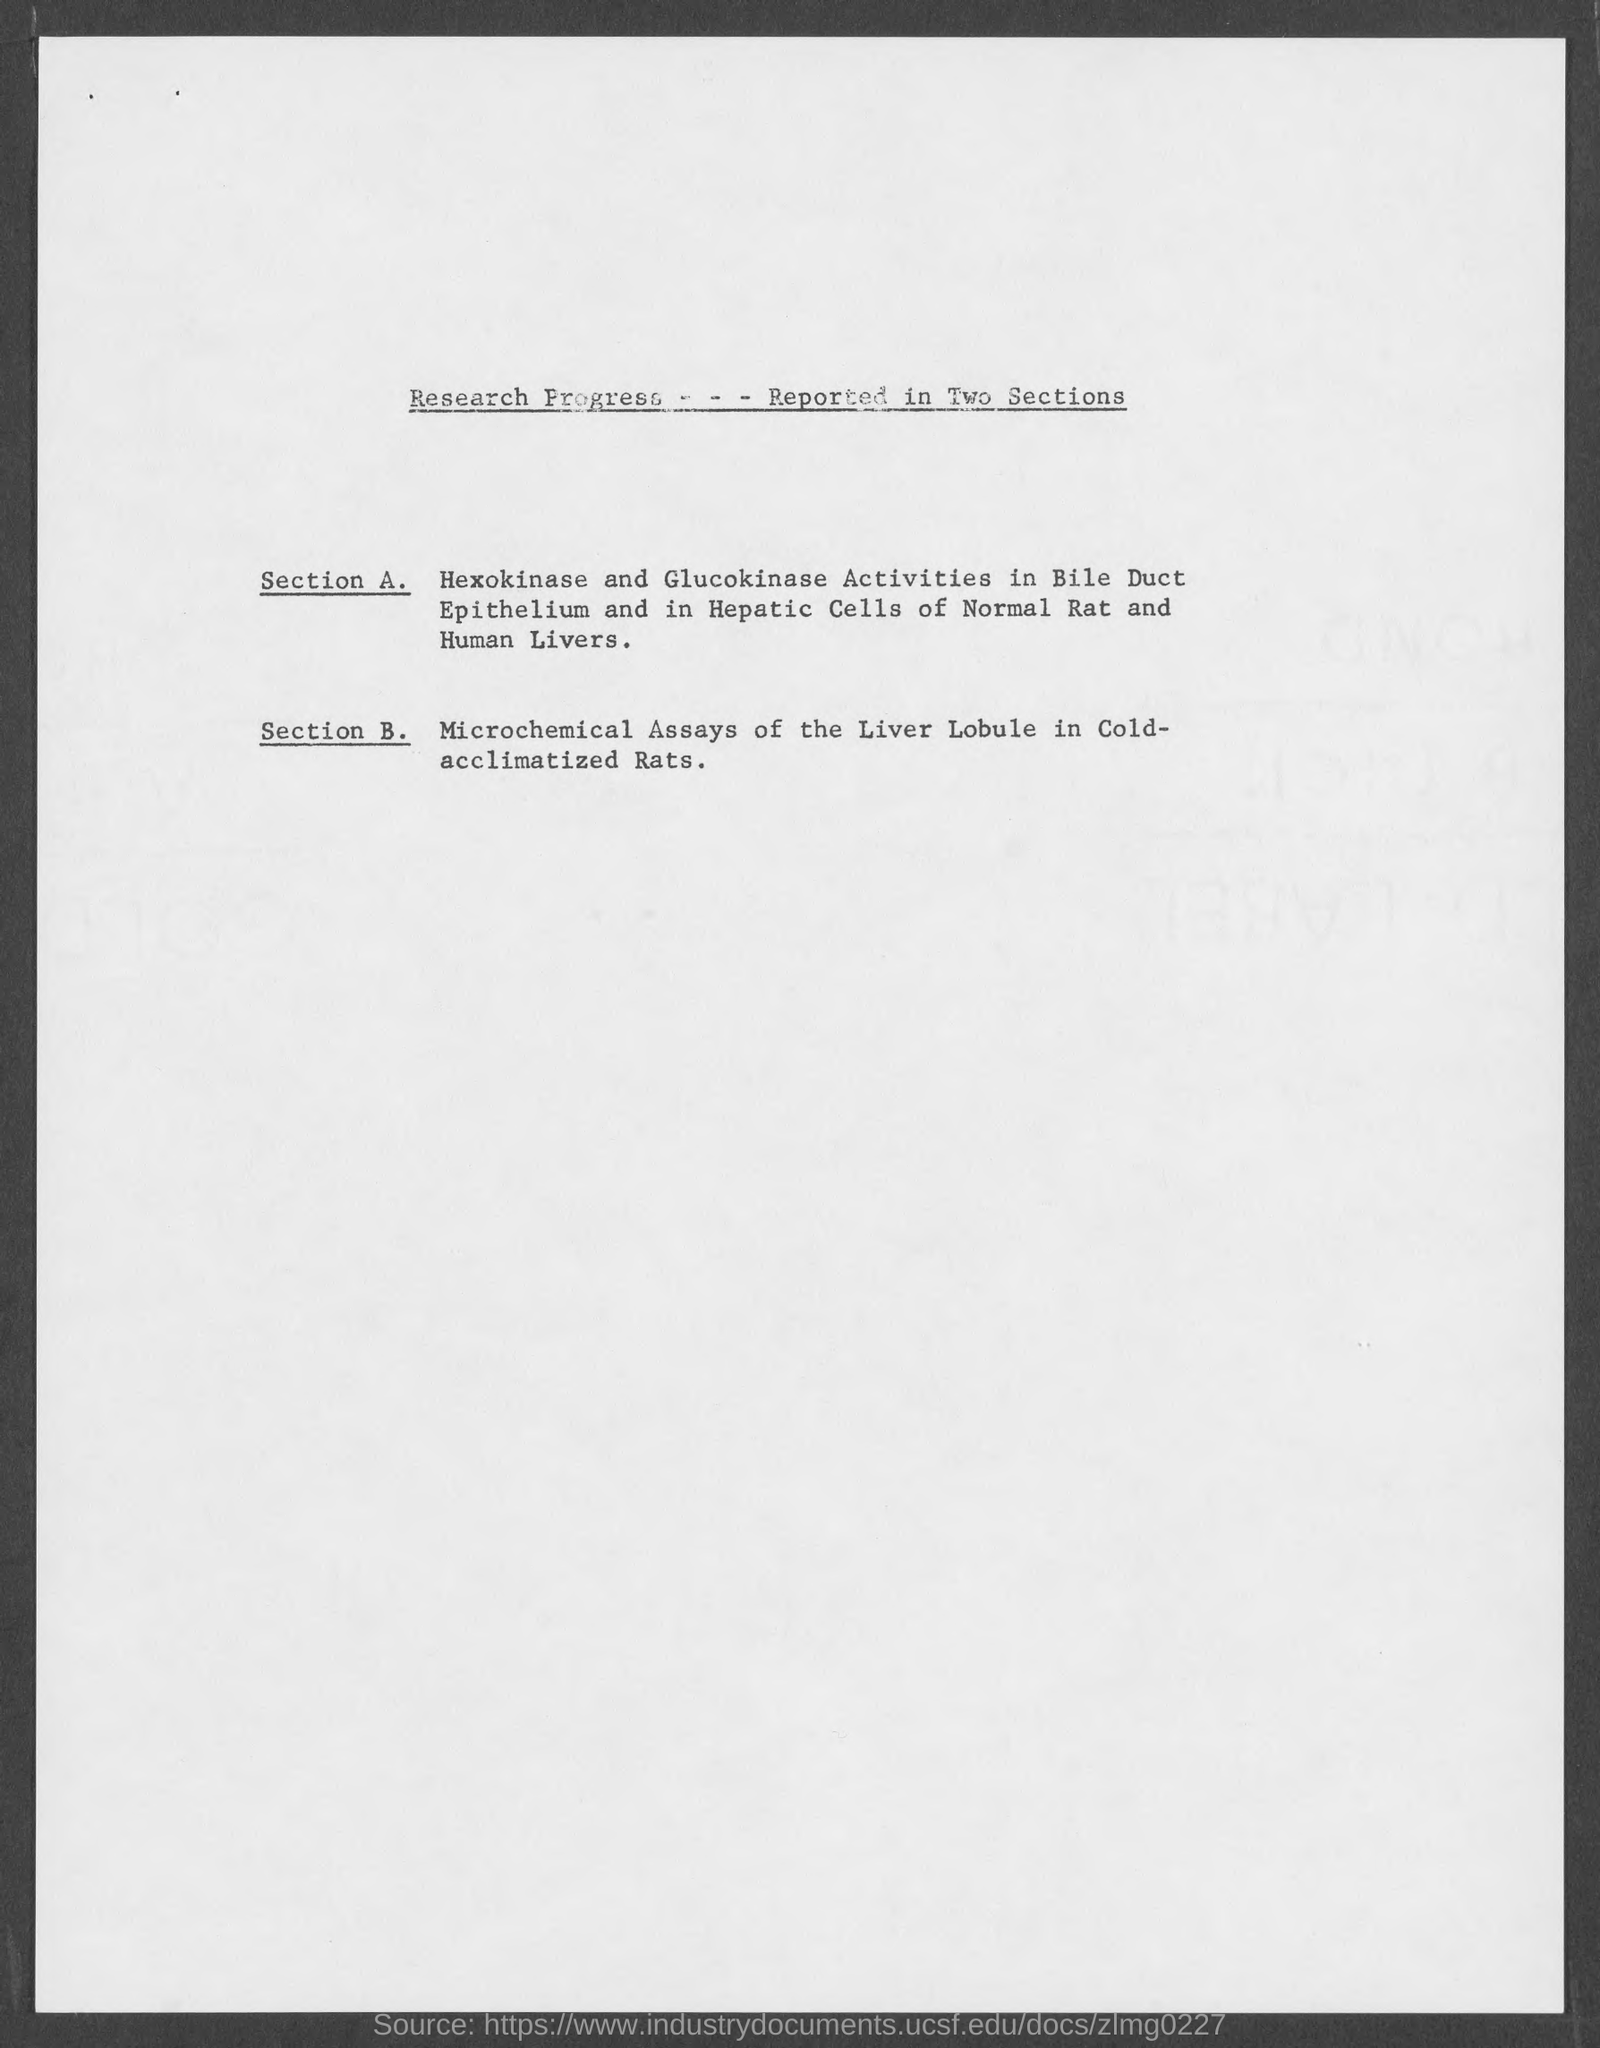Mention a couple of crucial points in this snapshot. This section examines the use of microchemical assays to study liver lobe function in cold-acclimated rats. 